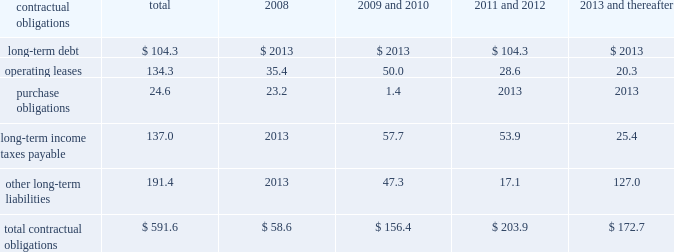Customary affirmative and negative covenants and events of default for an unsecured financing arrangement , including , among other things , limitations on consolidations , mergers and sales of assets .
Financial covenants include a maximum leverage ratio of 3.0 to 1.0 and a minimum interest coverage ratio of 3.5 to 1.0 .
If we fall below an investment grade credit rating , additional restrictions would result , including restrictions on investments , payment of dividends and stock repurchases .
We were in compliance with all covenants under the senior credit facility as of december 31 , 2007 .
Commitments under the senior credit facility are subject to certain fees , including a facility and a utilization fee .
The senior credit facility is rated a- by standard & poor 2019s ratings services and is not rated by moody 2019s investors 2019 service , inc .
We also have available uncommitted credit facilities totaling $ 70.4 million .
Management believes that cash flows from operations , together with available borrowings under the senior credit facility , are sufficient to meet our expected working capital , capital expenditure and debt service needs .
Should investment opportunities arise , we believe that our earnings , balance sheet and cash flows will allow us to obtain additional capital , if necessary .
Contractual obligations we have entered into contracts with various third parties in the normal course of business which will require future payments .
The table illustrates our contractual obligations ( in millions ) : contractual obligations total 2008 thereafter .
Total contractual obligations $ 591.6 $ 58.6 $ 156.4 $ 203.9 $ 172.7 critical accounting estimates our financial results are affected by the selection and application of accounting policies and methods .
Significant accounting policies which require management 2019s judgment are discussed below .
Excess inventory and instruments 2013 we must determine as of each balance sheet date how much , if any , of our inventory may ultimately prove to be unsaleable or unsaleable at our carrying cost .
Similarly , we must also determine if instruments on hand will be put to productive use or remain undeployed as a result of excess supply .
Reserves are established to effectively adjust inventory and instruments to net realizable value .
To determine the appropriate level of reserves , we evaluate current stock levels in relation to historical and expected patterns of demand for all of our products and instrument systems and components .
The basis for the determination is generally the same for all inventory and instrument items and categories except for work-in-progress inventory , which is recorded at cost .
Obsolete or discontinued items are generally destroyed and completely written off .
Management evaluates the need for changes to valuation reserves based on market conditions , competitive offerings and other factors on a regular basis .
Income taxes fffd we estimate income tax expense and income tax liabilities and assets by taxable jurisdiction .
Realization of deferred tax assets in each taxable jurisdiction is dependent on our ability to generate future taxable income sufficient to realize the benefits .
We evaluate deferred tax assets on an ongoing basis and provide valuation allowances if it is determined to be 201cmore likely than not 201d that the deferred tax benefit will not be realized .
Federal income taxes are provided on the portion of the income of foreign subsidiaries that is expected to be remitted to the u.s .
We operate within numerous taxing jurisdictions .
We are subject to regulatory review or audit in virtually all of those jurisdictions and those reviews and audits may require extended periods of time to resolve .
We make use of all available information and make reasoned judgments regarding matters requiring interpretation in establishing tax expense , liabilities and reserves .
We believe adequate provisions exist for income taxes for all periods and jurisdictions subject to review or audit .
Commitments and contingencies 2013 accruals for product liability and other claims are established with internal and external legal counsel based on current information and historical settlement information for claims , related fees and for claims incurred but not reported .
We use an actuarial model to assist management in determining an appropriate level of accruals for product liability claims .
Historical patterns of claim loss development over time are statistically analyzed to arrive at factors which are then applied to loss estimates in the actuarial model .
The amounts established equate to less than 5 percent of total liabilities and represent management 2019s best estimate of the ultimate costs that we will incur under the various contingencies .
Goodwill and intangible assets 2013 we evaluate the carrying value of goodwill and indefinite life intangible assets annually , or whenever events or circumstances indicate the carrying value may not be recoverable .
We evaluate the carrying value of finite life intangible assets whenever events or circumstances indicate the carrying value may not be recoverable .
Significant assumptions are required to estimate the fair value of goodwill and intangible assets , most notably estimated future cash flows generated by these assets .
As such , these fair valuation measurements use significant unobservable inputs as defined under statement of financial accounting standards no .
157 , fair value measurements .
Changes to these assumptions could require us to record impairment charges on these assets .
Share-based payment 2013 we account for share-based payment expense in accordance with the fair value z i m m e r h o l d i n g s , i n c .
2 0 0 7 f o r m 1 0 - k a n n u a l r e p o r t .
What percentage of total contractual obligations is long-term debt? 
Computations: (104.3 / 591.6)
Answer: 0.1763. 